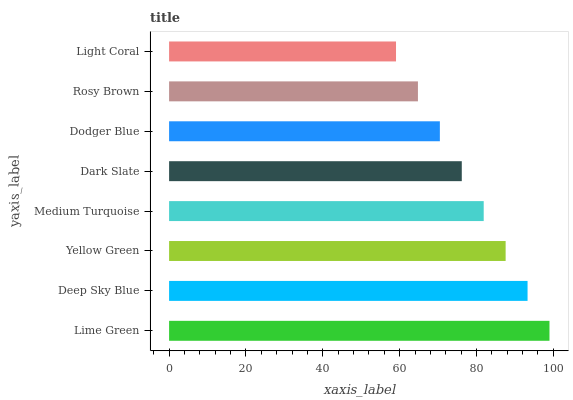Is Light Coral the minimum?
Answer yes or no. Yes. Is Lime Green the maximum?
Answer yes or no. Yes. Is Deep Sky Blue the minimum?
Answer yes or no. No. Is Deep Sky Blue the maximum?
Answer yes or no. No. Is Lime Green greater than Deep Sky Blue?
Answer yes or no. Yes. Is Deep Sky Blue less than Lime Green?
Answer yes or no. Yes. Is Deep Sky Blue greater than Lime Green?
Answer yes or no. No. Is Lime Green less than Deep Sky Blue?
Answer yes or no. No. Is Medium Turquoise the high median?
Answer yes or no. Yes. Is Dark Slate the low median?
Answer yes or no. Yes. Is Yellow Green the high median?
Answer yes or no. No. Is Dodger Blue the low median?
Answer yes or no. No. 